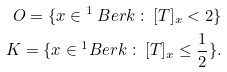<formula> <loc_0><loc_0><loc_500><loc_500>O = \{ x \in \AA ^ { 1 } _ { \ } B e r k \, \colon \, [ T ] _ { x } < 2 \} \\ K = \{ x \in \AA ^ { 1 } _ { \ } B e r k \, \colon \, [ T ] _ { x } \leq \frac { 1 } { 2 } \} . \\</formula> 